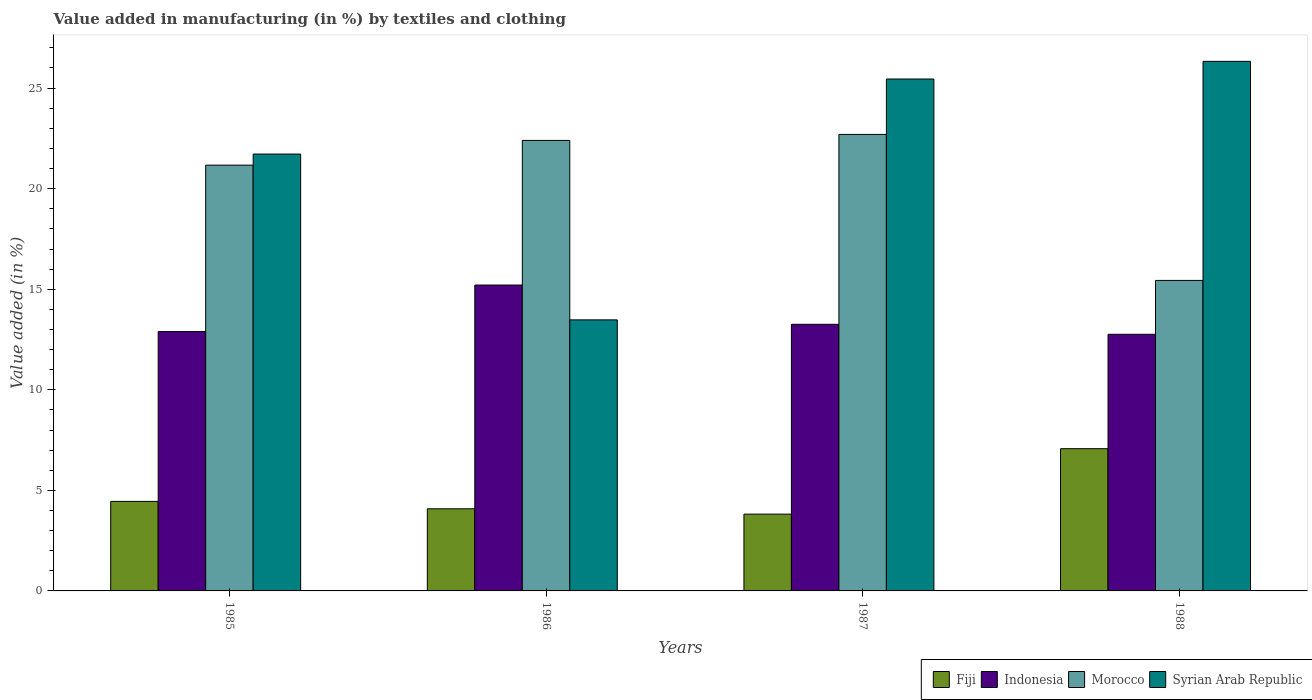Are the number of bars on each tick of the X-axis equal?
Your answer should be compact. Yes. How many bars are there on the 1st tick from the right?
Keep it short and to the point. 4. In how many cases, is the number of bars for a given year not equal to the number of legend labels?
Ensure brevity in your answer.  0. What is the percentage of value added in manufacturing by textiles and clothing in Morocco in 1988?
Keep it short and to the point. 15.44. Across all years, what is the maximum percentage of value added in manufacturing by textiles and clothing in Syrian Arab Republic?
Offer a very short reply. 26.33. Across all years, what is the minimum percentage of value added in manufacturing by textiles and clothing in Syrian Arab Republic?
Make the answer very short. 13.48. In which year was the percentage of value added in manufacturing by textiles and clothing in Indonesia maximum?
Provide a short and direct response. 1986. In which year was the percentage of value added in manufacturing by textiles and clothing in Fiji minimum?
Offer a very short reply. 1987. What is the total percentage of value added in manufacturing by textiles and clothing in Fiji in the graph?
Provide a short and direct response. 19.42. What is the difference between the percentage of value added in manufacturing by textiles and clothing in Syrian Arab Republic in 1985 and that in 1988?
Provide a short and direct response. -4.61. What is the difference between the percentage of value added in manufacturing by textiles and clothing in Fiji in 1988 and the percentage of value added in manufacturing by textiles and clothing in Syrian Arab Republic in 1985?
Make the answer very short. -14.65. What is the average percentage of value added in manufacturing by textiles and clothing in Morocco per year?
Give a very brief answer. 20.43. In the year 1987, what is the difference between the percentage of value added in manufacturing by textiles and clothing in Syrian Arab Republic and percentage of value added in manufacturing by textiles and clothing in Morocco?
Ensure brevity in your answer.  2.75. In how many years, is the percentage of value added in manufacturing by textiles and clothing in Morocco greater than 5 %?
Ensure brevity in your answer.  4. What is the ratio of the percentage of value added in manufacturing by textiles and clothing in Fiji in 1985 to that in 1986?
Offer a terse response. 1.09. Is the percentage of value added in manufacturing by textiles and clothing in Fiji in 1986 less than that in 1987?
Ensure brevity in your answer.  No. Is the difference between the percentage of value added in manufacturing by textiles and clothing in Syrian Arab Republic in 1985 and 1988 greater than the difference between the percentage of value added in manufacturing by textiles and clothing in Morocco in 1985 and 1988?
Your answer should be compact. No. What is the difference between the highest and the second highest percentage of value added in manufacturing by textiles and clothing in Fiji?
Your response must be concise. 2.62. What is the difference between the highest and the lowest percentage of value added in manufacturing by textiles and clothing in Syrian Arab Republic?
Keep it short and to the point. 12.85. Is the sum of the percentage of value added in manufacturing by textiles and clothing in Indonesia in 1987 and 1988 greater than the maximum percentage of value added in manufacturing by textiles and clothing in Morocco across all years?
Provide a short and direct response. Yes. Is it the case that in every year, the sum of the percentage of value added in manufacturing by textiles and clothing in Morocco and percentage of value added in manufacturing by textiles and clothing in Indonesia is greater than the sum of percentage of value added in manufacturing by textiles and clothing in Syrian Arab Republic and percentage of value added in manufacturing by textiles and clothing in Fiji?
Your answer should be compact. No. What does the 4th bar from the left in 1988 represents?
Your answer should be compact. Syrian Arab Republic. What does the 2nd bar from the right in 1987 represents?
Provide a short and direct response. Morocco. How many bars are there?
Provide a short and direct response. 16. Are all the bars in the graph horizontal?
Your response must be concise. No. How many years are there in the graph?
Give a very brief answer. 4. What is the difference between two consecutive major ticks on the Y-axis?
Keep it short and to the point. 5. Does the graph contain any zero values?
Provide a short and direct response. No. Does the graph contain grids?
Provide a succinct answer. No. How many legend labels are there?
Make the answer very short. 4. What is the title of the graph?
Your answer should be very brief. Value added in manufacturing (in %) by textiles and clothing. What is the label or title of the X-axis?
Give a very brief answer. Years. What is the label or title of the Y-axis?
Give a very brief answer. Value added (in %). What is the Value added (in %) of Fiji in 1985?
Keep it short and to the point. 4.45. What is the Value added (in %) in Indonesia in 1985?
Provide a short and direct response. 12.9. What is the Value added (in %) in Morocco in 1985?
Your answer should be very brief. 21.17. What is the Value added (in %) in Syrian Arab Republic in 1985?
Your answer should be compact. 21.72. What is the Value added (in %) of Fiji in 1986?
Make the answer very short. 4.08. What is the Value added (in %) in Indonesia in 1986?
Offer a very short reply. 15.21. What is the Value added (in %) in Morocco in 1986?
Ensure brevity in your answer.  22.4. What is the Value added (in %) in Syrian Arab Republic in 1986?
Ensure brevity in your answer.  13.48. What is the Value added (in %) in Fiji in 1987?
Your answer should be very brief. 3.82. What is the Value added (in %) of Indonesia in 1987?
Your answer should be compact. 13.26. What is the Value added (in %) of Morocco in 1987?
Give a very brief answer. 22.7. What is the Value added (in %) of Syrian Arab Republic in 1987?
Make the answer very short. 25.45. What is the Value added (in %) in Fiji in 1988?
Your answer should be very brief. 7.07. What is the Value added (in %) of Indonesia in 1988?
Offer a terse response. 12.76. What is the Value added (in %) of Morocco in 1988?
Give a very brief answer. 15.44. What is the Value added (in %) of Syrian Arab Republic in 1988?
Your answer should be very brief. 26.33. Across all years, what is the maximum Value added (in %) of Fiji?
Provide a succinct answer. 7.07. Across all years, what is the maximum Value added (in %) of Indonesia?
Keep it short and to the point. 15.21. Across all years, what is the maximum Value added (in %) in Morocco?
Keep it short and to the point. 22.7. Across all years, what is the maximum Value added (in %) in Syrian Arab Republic?
Offer a terse response. 26.33. Across all years, what is the minimum Value added (in %) in Fiji?
Make the answer very short. 3.82. Across all years, what is the minimum Value added (in %) of Indonesia?
Provide a succinct answer. 12.76. Across all years, what is the minimum Value added (in %) of Morocco?
Offer a very short reply. 15.44. Across all years, what is the minimum Value added (in %) in Syrian Arab Republic?
Offer a very short reply. 13.48. What is the total Value added (in %) of Fiji in the graph?
Provide a short and direct response. 19.42. What is the total Value added (in %) in Indonesia in the graph?
Your answer should be compact. 54.12. What is the total Value added (in %) in Morocco in the graph?
Keep it short and to the point. 81.71. What is the total Value added (in %) in Syrian Arab Republic in the graph?
Your answer should be very brief. 86.98. What is the difference between the Value added (in %) in Fiji in 1985 and that in 1986?
Offer a very short reply. 0.37. What is the difference between the Value added (in %) of Indonesia in 1985 and that in 1986?
Provide a short and direct response. -2.31. What is the difference between the Value added (in %) in Morocco in 1985 and that in 1986?
Your answer should be very brief. -1.23. What is the difference between the Value added (in %) in Syrian Arab Republic in 1985 and that in 1986?
Offer a terse response. 8.24. What is the difference between the Value added (in %) in Fiji in 1985 and that in 1987?
Give a very brief answer. 0.63. What is the difference between the Value added (in %) of Indonesia in 1985 and that in 1987?
Keep it short and to the point. -0.36. What is the difference between the Value added (in %) in Morocco in 1985 and that in 1987?
Ensure brevity in your answer.  -1.53. What is the difference between the Value added (in %) of Syrian Arab Republic in 1985 and that in 1987?
Your response must be concise. -3.73. What is the difference between the Value added (in %) of Fiji in 1985 and that in 1988?
Your response must be concise. -2.62. What is the difference between the Value added (in %) in Indonesia in 1985 and that in 1988?
Ensure brevity in your answer.  0.13. What is the difference between the Value added (in %) of Morocco in 1985 and that in 1988?
Your response must be concise. 5.73. What is the difference between the Value added (in %) of Syrian Arab Republic in 1985 and that in 1988?
Ensure brevity in your answer.  -4.61. What is the difference between the Value added (in %) in Fiji in 1986 and that in 1987?
Provide a succinct answer. 0.27. What is the difference between the Value added (in %) in Indonesia in 1986 and that in 1987?
Your answer should be compact. 1.95. What is the difference between the Value added (in %) in Morocco in 1986 and that in 1987?
Ensure brevity in your answer.  -0.3. What is the difference between the Value added (in %) of Syrian Arab Republic in 1986 and that in 1987?
Provide a short and direct response. -11.98. What is the difference between the Value added (in %) in Fiji in 1986 and that in 1988?
Offer a terse response. -2.99. What is the difference between the Value added (in %) of Indonesia in 1986 and that in 1988?
Provide a succinct answer. 2.45. What is the difference between the Value added (in %) of Morocco in 1986 and that in 1988?
Keep it short and to the point. 6.96. What is the difference between the Value added (in %) of Syrian Arab Republic in 1986 and that in 1988?
Offer a terse response. -12.85. What is the difference between the Value added (in %) of Fiji in 1987 and that in 1988?
Make the answer very short. -3.25. What is the difference between the Value added (in %) of Indonesia in 1987 and that in 1988?
Provide a short and direct response. 0.5. What is the difference between the Value added (in %) of Morocco in 1987 and that in 1988?
Give a very brief answer. 7.26. What is the difference between the Value added (in %) in Syrian Arab Republic in 1987 and that in 1988?
Make the answer very short. -0.88. What is the difference between the Value added (in %) in Fiji in 1985 and the Value added (in %) in Indonesia in 1986?
Offer a terse response. -10.76. What is the difference between the Value added (in %) of Fiji in 1985 and the Value added (in %) of Morocco in 1986?
Ensure brevity in your answer.  -17.95. What is the difference between the Value added (in %) of Fiji in 1985 and the Value added (in %) of Syrian Arab Republic in 1986?
Provide a short and direct response. -9.03. What is the difference between the Value added (in %) of Indonesia in 1985 and the Value added (in %) of Morocco in 1986?
Keep it short and to the point. -9.5. What is the difference between the Value added (in %) of Indonesia in 1985 and the Value added (in %) of Syrian Arab Republic in 1986?
Provide a succinct answer. -0.58. What is the difference between the Value added (in %) of Morocco in 1985 and the Value added (in %) of Syrian Arab Republic in 1986?
Your answer should be very brief. 7.69. What is the difference between the Value added (in %) in Fiji in 1985 and the Value added (in %) in Indonesia in 1987?
Give a very brief answer. -8.81. What is the difference between the Value added (in %) of Fiji in 1985 and the Value added (in %) of Morocco in 1987?
Your answer should be very brief. -18.25. What is the difference between the Value added (in %) in Fiji in 1985 and the Value added (in %) in Syrian Arab Republic in 1987?
Keep it short and to the point. -21. What is the difference between the Value added (in %) in Indonesia in 1985 and the Value added (in %) in Morocco in 1987?
Provide a short and direct response. -9.8. What is the difference between the Value added (in %) in Indonesia in 1985 and the Value added (in %) in Syrian Arab Republic in 1987?
Your answer should be very brief. -12.56. What is the difference between the Value added (in %) of Morocco in 1985 and the Value added (in %) of Syrian Arab Republic in 1987?
Make the answer very short. -4.28. What is the difference between the Value added (in %) in Fiji in 1985 and the Value added (in %) in Indonesia in 1988?
Give a very brief answer. -8.31. What is the difference between the Value added (in %) of Fiji in 1985 and the Value added (in %) of Morocco in 1988?
Your response must be concise. -10.99. What is the difference between the Value added (in %) in Fiji in 1985 and the Value added (in %) in Syrian Arab Republic in 1988?
Ensure brevity in your answer.  -21.88. What is the difference between the Value added (in %) of Indonesia in 1985 and the Value added (in %) of Morocco in 1988?
Provide a succinct answer. -2.54. What is the difference between the Value added (in %) in Indonesia in 1985 and the Value added (in %) in Syrian Arab Republic in 1988?
Provide a short and direct response. -13.44. What is the difference between the Value added (in %) in Morocco in 1985 and the Value added (in %) in Syrian Arab Republic in 1988?
Offer a terse response. -5.16. What is the difference between the Value added (in %) of Fiji in 1986 and the Value added (in %) of Indonesia in 1987?
Provide a short and direct response. -9.17. What is the difference between the Value added (in %) of Fiji in 1986 and the Value added (in %) of Morocco in 1987?
Provide a short and direct response. -18.61. What is the difference between the Value added (in %) of Fiji in 1986 and the Value added (in %) of Syrian Arab Republic in 1987?
Your response must be concise. -21.37. What is the difference between the Value added (in %) of Indonesia in 1986 and the Value added (in %) of Morocco in 1987?
Make the answer very short. -7.49. What is the difference between the Value added (in %) of Indonesia in 1986 and the Value added (in %) of Syrian Arab Republic in 1987?
Give a very brief answer. -10.24. What is the difference between the Value added (in %) in Morocco in 1986 and the Value added (in %) in Syrian Arab Republic in 1987?
Provide a short and direct response. -3.05. What is the difference between the Value added (in %) of Fiji in 1986 and the Value added (in %) of Indonesia in 1988?
Give a very brief answer. -8.68. What is the difference between the Value added (in %) in Fiji in 1986 and the Value added (in %) in Morocco in 1988?
Your response must be concise. -11.35. What is the difference between the Value added (in %) in Fiji in 1986 and the Value added (in %) in Syrian Arab Republic in 1988?
Your response must be concise. -22.25. What is the difference between the Value added (in %) of Indonesia in 1986 and the Value added (in %) of Morocco in 1988?
Ensure brevity in your answer.  -0.23. What is the difference between the Value added (in %) in Indonesia in 1986 and the Value added (in %) in Syrian Arab Republic in 1988?
Your response must be concise. -11.12. What is the difference between the Value added (in %) of Morocco in 1986 and the Value added (in %) of Syrian Arab Republic in 1988?
Your response must be concise. -3.93. What is the difference between the Value added (in %) in Fiji in 1987 and the Value added (in %) in Indonesia in 1988?
Keep it short and to the point. -8.94. What is the difference between the Value added (in %) in Fiji in 1987 and the Value added (in %) in Morocco in 1988?
Provide a short and direct response. -11.62. What is the difference between the Value added (in %) of Fiji in 1987 and the Value added (in %) of Syrian Arab Republic in 1988?
Give a very brief answer. -22.51. What is the difference between the Value added (in %) in Indonesia in 1987 and the Value added (in %) in Morocco in 1988?
Give a very brief answer. -2.18. What is the difference between the Value added (in %) in Indonesia in 1987 and the Value added (in %) in Syrian Arab Republic in 1988?
Make the answer very short. -13.07. What is the difference between the Value added (in %) of Morocco in 1987 and the Value added (in %) of Syrian Arab Republic in 1988?
Your answer should be very brief. -3.63. What is the average Value added (in %) in Fiji per year?
Keep it short and to the point. 4.86. What is the average Value added (in %) in Indonesia per year?
Offer a terse response. 13.53. What is the average Value added (in %) of Morocco per year?
Ensure brevity in your answer.  20.43. What is the average Value added (in %) of Syrian Arab Republic per year?
Provide a short and direct response. 21.75. In the year 1985, what is the difference between the Value added (in %) of Fiji and Value added (in %) of Indonesia?
Your answer should be compact. -8.44. In the year 1985, what is the difference between the Value added (in %) of Fiji and Value added (in %) of Morocco?
Provide a succinct answer. -16.72. In the year 1985, what is the difference between the Value added (in %) of Fiji and Value added (in %) of Syrian Arab Republic?
Your response must be concise. -17.27. In the year 1985, what is the difference between the Value added (in %) in Indonesia and Value added (in %) in Morocco?
Provide a succinct answer. -8.28. In the year 1985, what is the difference between the Value added (in %) of Indonesia and Value added (in %) of Syrian Arab Republic?
Provide a succinct answer. -8.83. In the year 1985, what is the difference between the Value added (in %) in Morocco and Value added (in %) in Syrian Arab Republic?
Provide a short and direct response. -0.55. In the year 1986, what is the difference between the Value added (in %) in Fiji and Value added (in %) in Indonesia?
Keep it short and to the point. -11.12. In the year 1986, what is the difference between the Value added (in %) of Fiji and Value added (in %) of Morocco?
Your response must be concise. -18.32. In the year 1986, what is the difference between the Value added (in %) of Fiji and Value added (in %) of Syrian Arab Republic?
Offer a terse response. -9.39. In the year 1986, what is the difference between the Value added (in %) in Indonesia and Value added (in %) in Morocco?
Keep it short and to the point. -7.19. In the year 1986, what is the difference between the Value added (in %) of Indonesia and Value added (in %) of Syrian Arab Republic?
Make the answer very short. 1.73. In the year 1986, what is the difference between the Value added (in %) of Morocco and Value added (in %) of Syrian Arab Republic?
Ensure brevity in your answer.  8.92. In the year 1987, what is the difference between the Value added (in %) of Fiji and Value added (in %) of Indonesia?
Make the answer very short. -9.44. In the year 1987, what is the difference between the Value added (in %) of Fiji and Value added (in %) of Morocco?
Your answer should be compact. -18.88. In the year 1987, what is the difference between the Value added (in %) in Fiji and Value added (in %) in Syrian Arab Republic?
Ensure brevity in your answer.  -21.63. In the year 1987, what is the difference between the Value added (in %) in Indonesia and Value added (in %) in Morocco?
Your response must be concise. -9.44. In the year 1987, what is the difference between the Value added (in %) in Indonesia and Value added (in %) in Syrian Arab Republic?
Provide a short and direct response. -12.2. In the year 1987, what is the difference between the Value added (in %) of Morocco and Value added (in %) of Syrian Arab Republic?
Provide a succinct answer. -2.75. In the year 1988, what is the difference between the Value added (in %) in Fiji and Value added (in %) in Indonesia?
Provide a short and direct response. -5.69. In the year 1988, what is the difference between the Value added (in %) in Fiji and Value added (in %) in Morocco?
Your response must be concise. -8.37. In the year 1988, what is the difference between the Value added (in %) of Fiji and Value added (in %) of Syrian Arab Republic?
Your answer should be very brief. -19.26. In the year 1988, what is the difference between the Value added (in %) of Indonesia and Value added (in %) of Morocco?
Make the answer very short. -2.68. In the year 1988, what is the difference between the Value added (in %) of Indonesia and Value added (in %) of Syrian Arab Republic?
Provide a succinct answer. -13.57. In the year 1988, what is the difference between the Value added (in %) of Morocco and Value added (in %) of Syrian Arab Republic?
Provide a short and direct response. -10.89. What is the ratio of the Value added (in %) of Fiji in 1985 to that in 1986?
Provide a succinct answer. 1.09. What is the ratio of the Value added (in %) in Indonesia in 1985 to that in 1986?
Offer a terse response. 0.85. What is the ratio of the Value added (in %) of Morocco in 1985 to that in 1986?
Provide a succinct answer. 0.95. What is the ratio of the Value added (in %) of Syrian Arab Republic in 1985 to that in 1986?
Ensure brevity in your answer.  1.61. What is the ratio of the Value added (in %) of Fiji in 1985 to that in 1987?
Provide a short and direct response. 1.17. What is the ratio of the Value added (in %) of Indonesia in 1985 to that in 1987?
Keep it short and to the point. 0.97. What is the ratio of the Value added (in %) of Morocco in 1985 to that in 1987?
Make the answer very short. 0.93. What is the ratio of the Value added (in %) in Syrian Arab Republic in 1985 to that in 1987?
Ensure brevity in your answer.  0.85. What is the ratio of the Value added (in %) of Fiji in 1985 to that in 1988?
Offer a terse response. 0.63. What is the ratio of the Value added (in %) in Indonesia in 1985 to that in 1988?
Make the answer very short. 1.01. What is the ratio of the Value added (in %) of Morocco in 1985 to that in 1988?
Offer a terse response. 1.37. What is the ratio of the Value added (in %) of Syrian Arab Republic in 1985 to that in 1988?
Your response must be concise. 0.82. What is the ratio of the Value added (in %) in Fiji in 1986 to that in 1987?
Offer a terse response. 1.07. What is the ratio of the Value added (in %) in Indonesia in 1986 to that in 1987?
Keep it short and to the point. 1.15. What is the ratio of the Value added (in %) of Morocco in 1986 to that in 1987?
Give a very brief answer. 0.99. What is the ratio of the Value added (in %) in Syrian Arab Republic in 1986 to that in 1987?
Your answer should be compact. 0.53. What is the ratio of the Value added (in %) of Fiji in 1986 to that in 1988?
Your answer should be compact. 0.58. What is the ratio of the Value added (in %) in Indonesia in 1986 to that in 1988?
Offer a very short reply. 1.19. What is the ratio of the Value added (in %) of Morocco in 1986 to that in 1988?
Offer a very short reply. 1.45. What is the ratio of the Value added (in %) in Syrian Arab Republic in 1986 to that in 1988?
Give a very brief answer. 0.51. What is the ratio of the Value added (in %) of Fiji in 1987 to that in 1988?
Provide a succinct answer. 0.54. What is the ratio of the Value added (in %) in Indonesia in 1987 to that in 1988?
Your answer should be compact. 1.04. What is the ratio of the Value added (in %) in Morocco in 1987 to that in 1988?
Provide a short and direct response. 1.47. What is the ratio of the Value added (in %) of Syrian Arab Republic in 1987 to that in 1988?
Your answer should be compact. 0.97. What is the difference between the highest and the second highest Value added (in %) of Fiji?
Your answer should be compact. 2.62. What is the difference between the highest and the second highest Value added (in %) in Indonesia?
Your response must be concise. 1.95. What is the difference between the highest and the second highest Value added (in %) of Morocco?
Your answer should be compact. 0.3. What is the difference between the highest and the second highest Value added (in %) in Syrian Arab Republic?
Ensure brevity in your answer.  0.88. What is the difference between the highest and the lowest Value added (in %) in Fiji?
Offer a terse response. 3.25. What is the difference between the highest and the lowest Value added (in %) in Indonesia?
Your response must be concise. 2.45. What is the difference between the highest and the lowest Value added (in %) of Morocco?
Offer a terse response. 7.26. What is the difference between the highest and the lowest Value added (in %) in Syrian Arab Republic?
Offer a terse response. 12.85. 